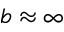<formula> <loc_0><loc_0><loc_500><loc_500>b \approx \infty</formula> 